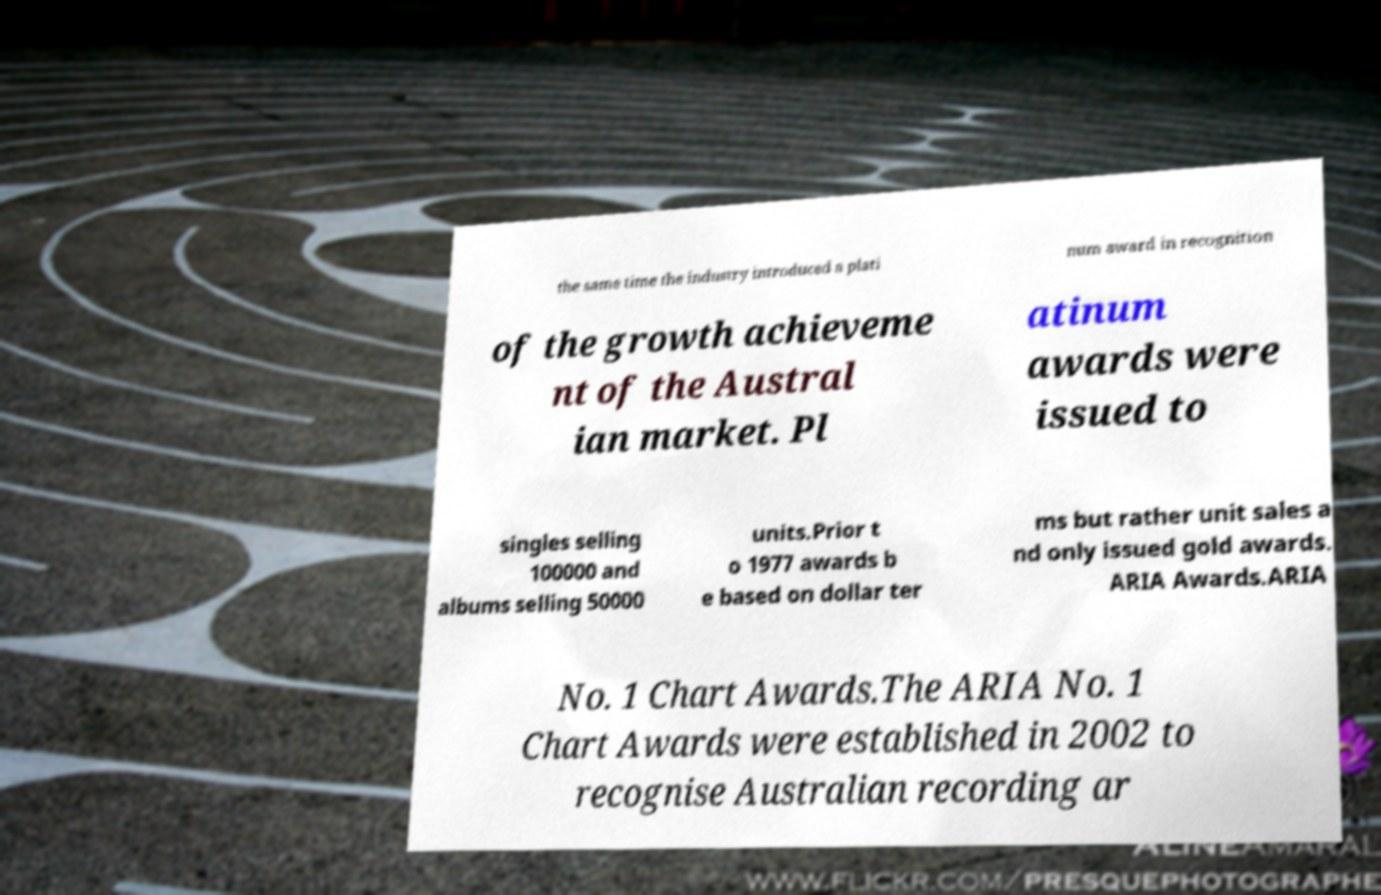I need the written content from this picture converted into text. Can you do that? the same time the industry introduced a plati num award in recognition of the growth achieveme nt of the Austral ian market. Pl atinum awards were issued to singles selling 100000 and albums selling 50000 units.Prior t o 1977 awards b e based on dollar ter ms but rather unit sales a nd only issued gold awards. ARIA Awards.ARIA No. 1 Chart Awards.The ARIA No. 1 Chart Awards were established in 2002 to recognise Australian recording ar 